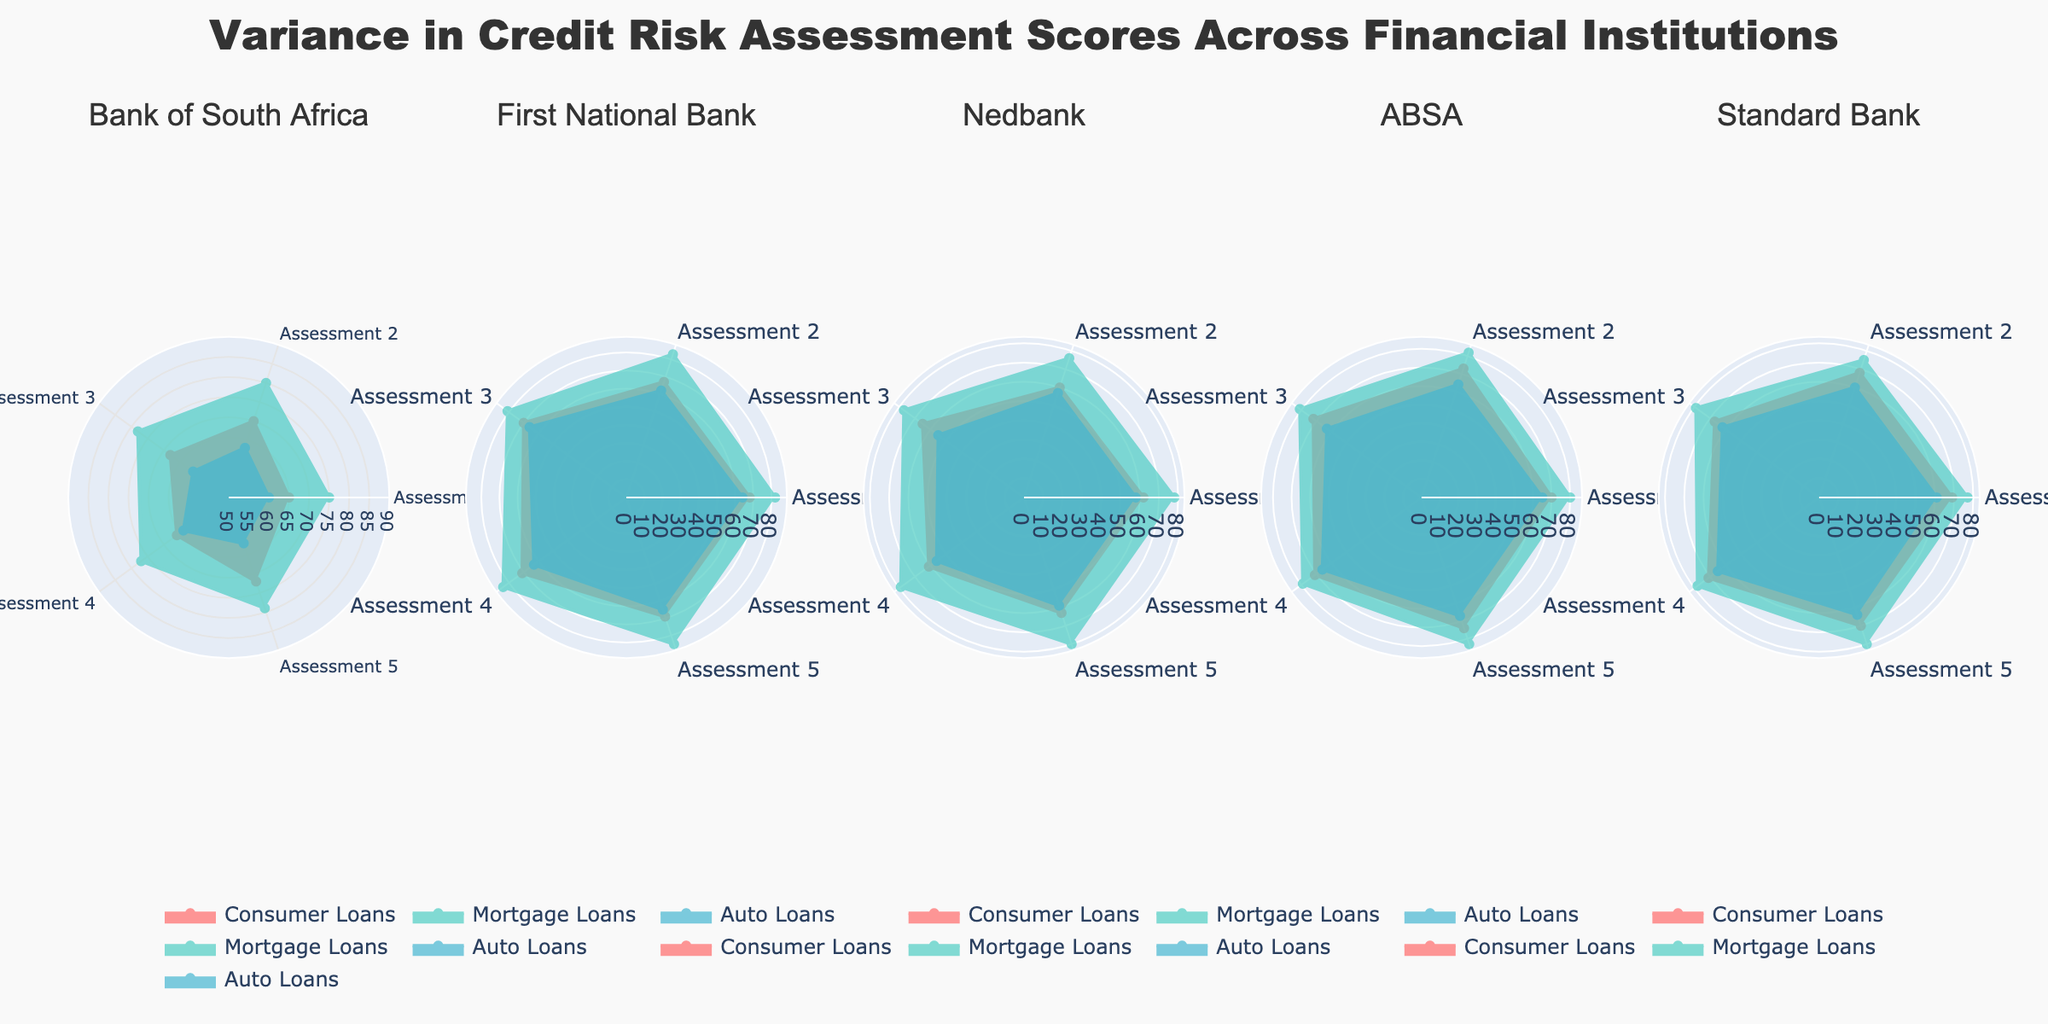What is the title of the figure? The title is located at the top of the figure and reads "Variance in Credit Risk Assessment Scores Across Financial Institutions."
Answer: Variance in Credit Risk Assessment Scores Across Financial Institutions What is the range of the radial axis in this figure? The radial axis range is visible on each subplot and spans from 50 to 90.
Answer: 50 to 90 How many different financial institutions are represented in the subplots? There is one subplot for each unique financial institution. From the subplot titles, we see there are five institutions: Bank of South Africa, First National Bank, Nedbank, ABSA, and Standard Bank.
Answer: 5 Which subcategory has the highest credit risk assessment score for First National Bank? By looking at the First National Bank subplot, the Mortgage Loans subcategory has the highest scores among the three categories.
Answer: Mortgage Loans Compare the assessment scores of Consumer Loans between Bank of South Africa and Standard Bank. Which one is higher on average? Summing the values for Consumer Loans in both institutions and dividing by 5, Bank of South Africa: (65+70+68+66+72)/5 = 68.2, Standard Bank: (69+68+67+71+70)/5 = 69. So, Standard Bank has a slightly higher average.
Answer: Standard Bank What is the color used to represent the Auto Loans sub-category in the plot? Auto Loans are colored using the third color in all subplots. From the color legend, the color used for Auto Loans is a shade of blue (#45B7D1).
Answer: Blue Which institution has the lowest assessment score for Auto Loans, and what is that score? Looking at the Auto Loans radial plot for each institution, Nedbank has the lowest assessment score at 55.
Answer: Nedbank, 55 For the credit risk assessments displayed, which institution shows the least variance in scores for Mortgage Loans? By visually comparing the spread of the lines in the Mortgage Loans subplot, First National Bank shows the least variance in the scores for Mortgage Loans.
Answer: First National Bank What is the average credit risk assessment score for Mortgage Loans in ABSA? The scores for ABSA Mortgage Loans are 80, 82, 81, 79, 83. Summing these values and dividing by 5 gives (80+82+81+79+83)/5 = 81.
Answer: 81 How does Nedbank's performance in Consumer Loans compare to its performance in Auto Loans? Comparing the scores of Consumer Loans and Auto Loans for Nedbank, Consumer Loans have higher scores with the average (62+60+65+61+63)/5 = 62.2 compared to Auto Loans (58+57+55+56+59)/5 = 57.
Answer: Consumer Loans perform better 